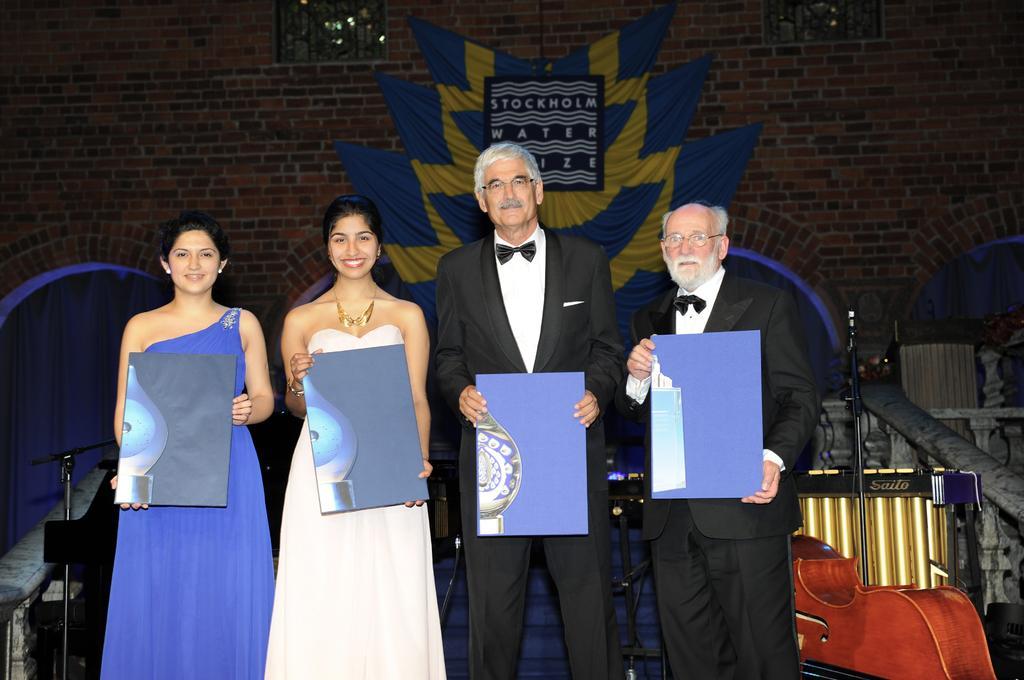How would you summarize this image in a sentence or two? This image is taken indoors. In the background there is a wall with a painting and a window and there are a few musical instruments. In the middle of the image two men and two women are standing on the dais and holding something in their hands. 